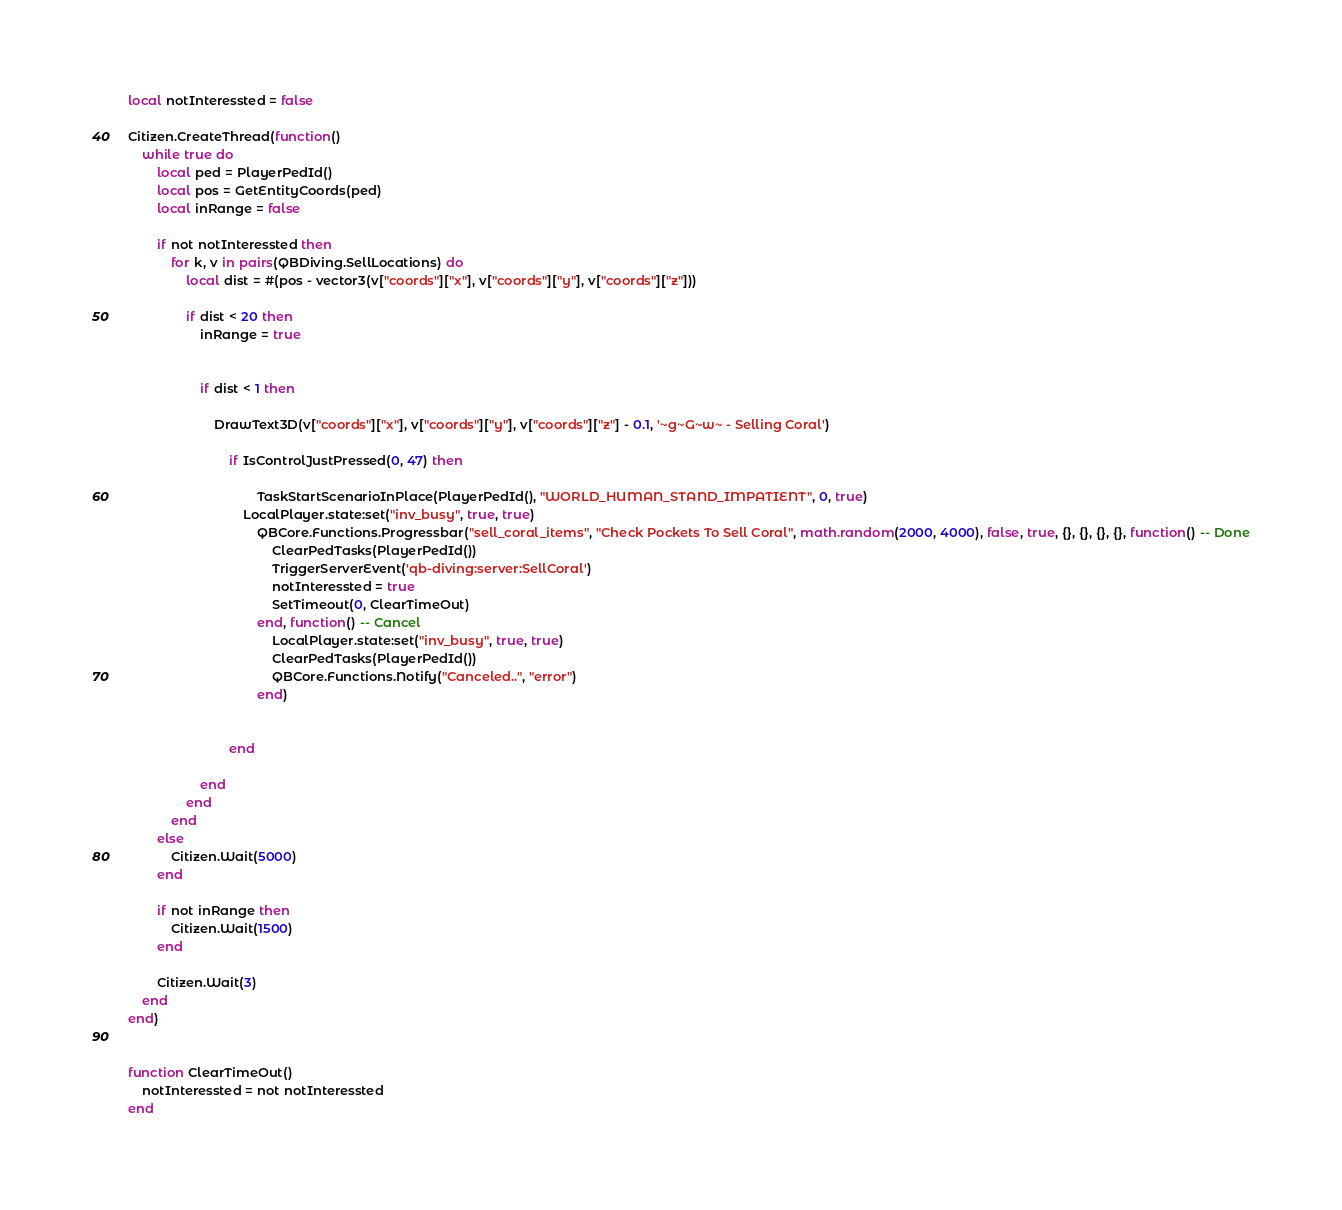<code> <loc_0><loc_0><loc_500><loc_500><_Lua_>

local notInteressted = false

Citizen.CreateThread(function()
    while true do
        local ped = PlayerPedId()
        local pos = GetEntityCoords(ped)
        local inRange = false

        if not notInteressted then
            for k, v in pairs(QBDiving.SellLocations) do
                local dist = #(pos - vector3(v["coords"]["x"], v["coords"]["y"], v["coords"]["z"]))
                
                if dist < 20 then
                    inRange = true


                    if dist < 1 then
                        
                        DrawText3D(v["coords"]["x"], v["coords"]["y"], v["coords"]["z"] - 0.1, '~g~G~w~ - Selling Coral')
                        
                            if IsControlJustPressed(0, 47) then
                    
                                    TaskStartScenarioInPlace(PlayerPedId(), "WORLD_HUMAN_STAND_IMPATIENT", 0, true)
                                LocalPlayer.state:set("inv_busy", true, true)
                                    QBCore.Functions.Progressbar("sell_coral_items", "Check Pockets To Sell Coral", math.random(2000, 4000), false, true, {}, {}, {}, {}, function() -- Done
                                        ClearPedTasks(PlayerPedId())
                                        TriggerServerEvent('qb-diving:server:SellCoral')
                                        notInteressted = true
                                        SetTimeout(0, ClearTimeOut)
                                    end, function() -- Cancel
                                        LocalPlayer.state:set("inv_busy", true, true)
                                        ClearPedTasks(PlayerPedId())
                                        QBCore.Functions.Notify("Canceled..", "error")
                                    end)
                               
                                
                            end
                        
                    end
                end
            end
        else
            Citizen.Wait(5000)
        end

        if not inRange then
            Citizen.Wait(1500)
        end

        Citizen.Wait(3)
    end
end)


function ClearTimeOut()
    notInteressted = not notInteressted
end
</code> 